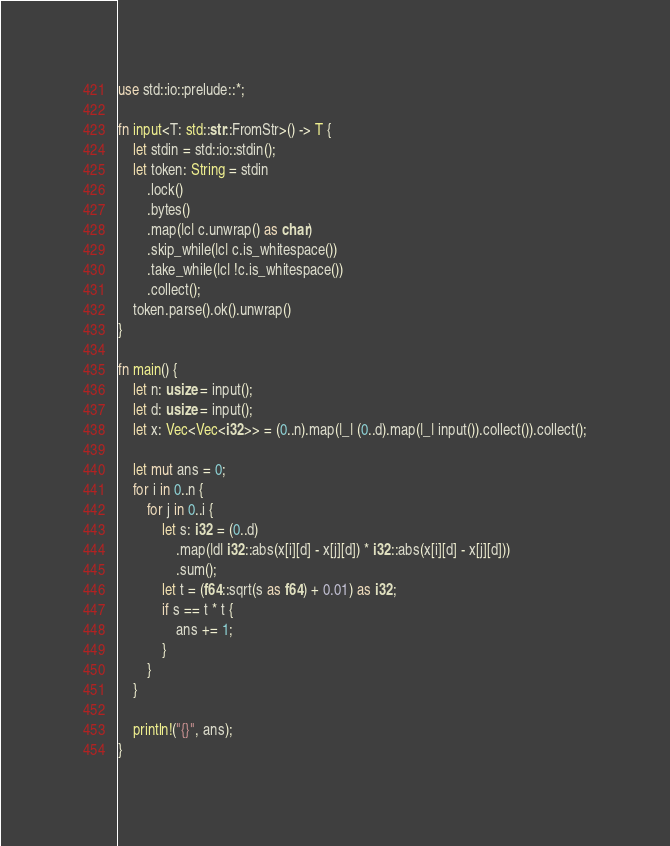<code> <loc_0><loc_0><loc_500><loc_500><_Rust_>use std::io::prelude::*;

fn input<T: std::str::FromStr>() -> T {
    let stdin = std::io::stdin();
    let token: String = stdin
        .lock()
        .bytes()
        .map(|c| c.unwrap() as char)
        .skip_while(|c| c.is_whitespace())
        .take_while(|c| !c.is_whitespace())
        .collect();
    token.parse().ok().unwrap()
}

fn main() {
    let n: usize = input();
    let d: usize = input();
    let x: Vec<Vec<i32>> = (0..n).map(|_| (0..d).map(|_| input()).collect()).collect();

    let mut ans = 0;
    for i in 0..n {
        for j in 0..i {
            let s: i32 = (0..d)
                .map(|d| i32::abs(x[i][d] - x[j][d]) * i32::abs(x[i][d] - x[j][d]))
                .sum();
            let t = (f64::sqrt(s as f64) + 0.01) as i32;
            if s == t * t {
                ans += 1;
            }
        }
    }

    println!("{}", ans);
}
</code> 